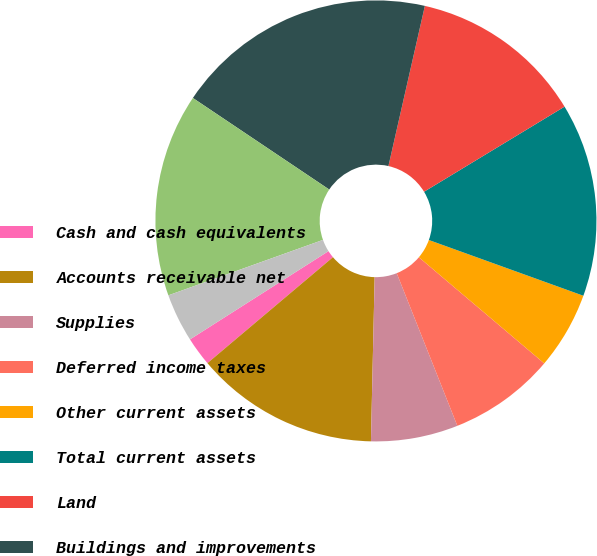Convert chart to OTSL. <chart><loc_0><loc_0><loc_500><loc_500><pie_chart><fcel>Cash and cash equivalents<fcel>Accounts receivable net<fcel>Supplies<fcel>Deferred income taxes<fcel>Other current assets<fcel>Total current assets<fcel>Land<fcel>Buildings and improvements<fcel>Equipment<fcel>Property under capital lease<nl><fcel>2.13%<fcel>13.48%<fcel>6.38%<fcel>7.8%<fcel>5.67%<fcel>14.18%<fcel>12.77%<fcel>19.15%<fcel>14.89%<fcel>3.55%<nl></chart> 